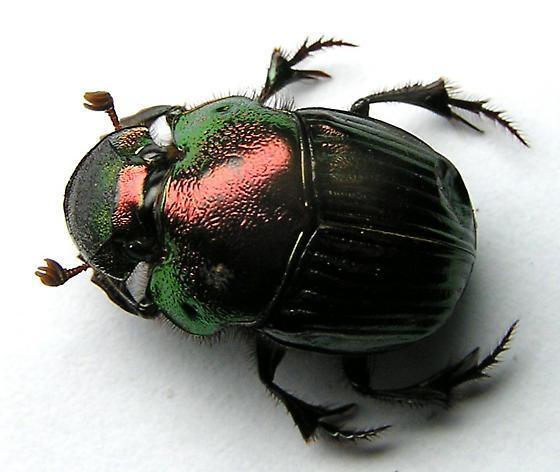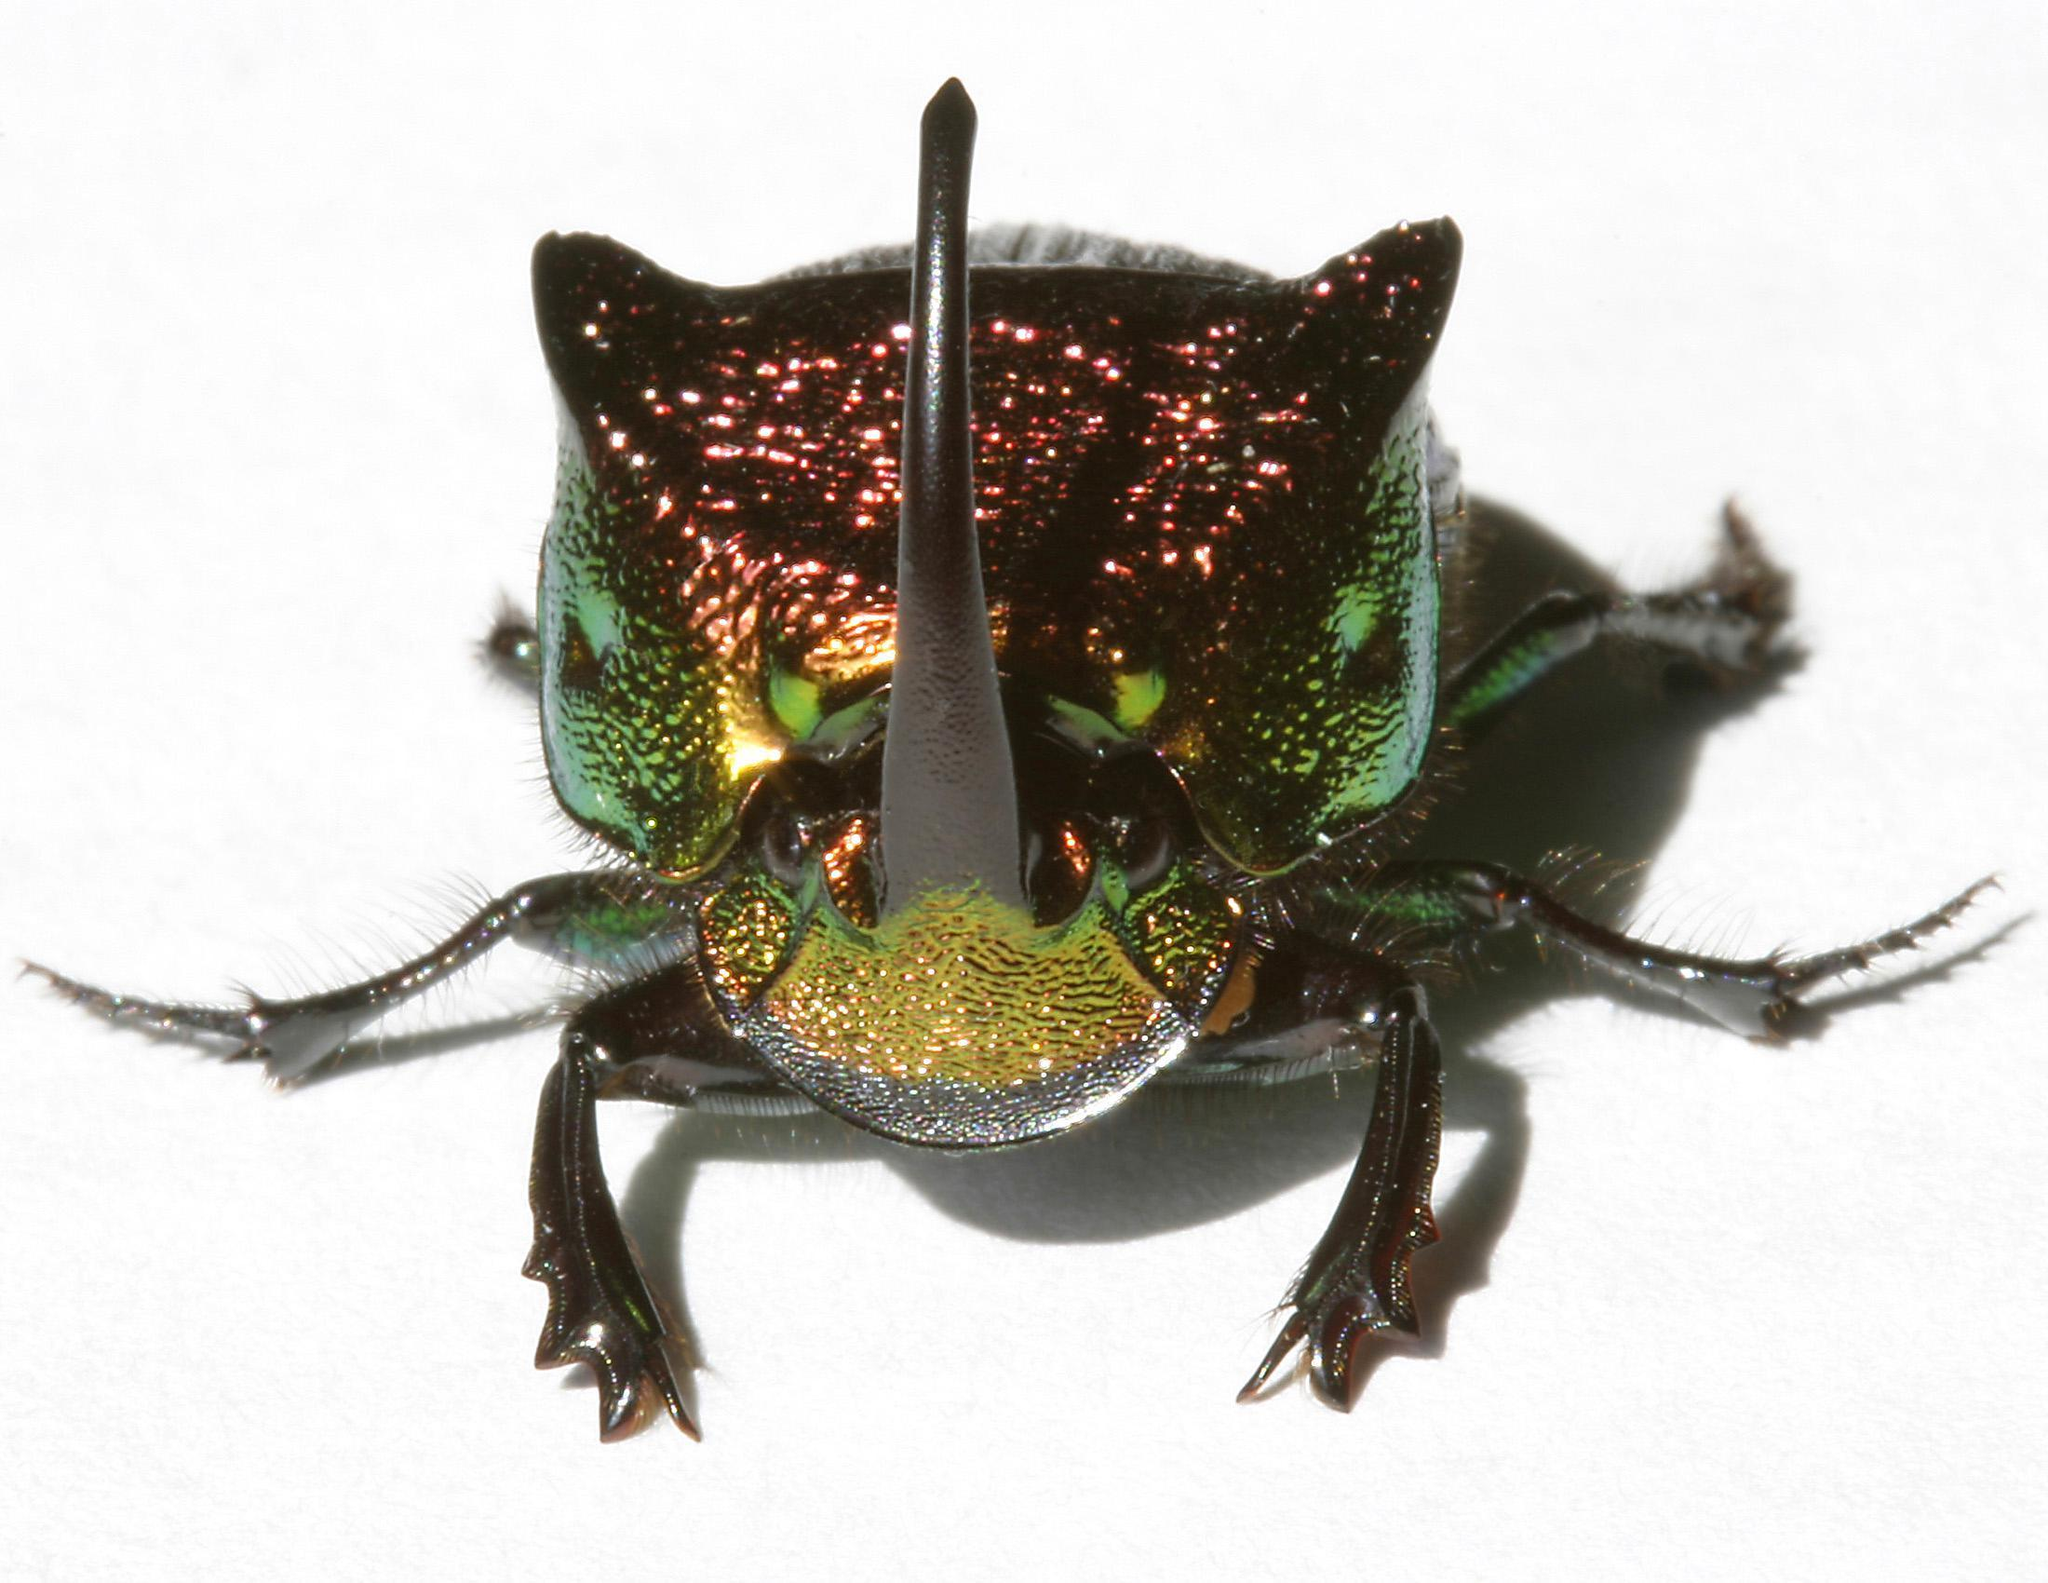The first image is the image on the left, the second image is the image on the right. Given the left and right images, does the statement "At least one image shows a single beetle that is iridescent green with iridescent red highlights." hold true? Answer yes or no. Yes. 